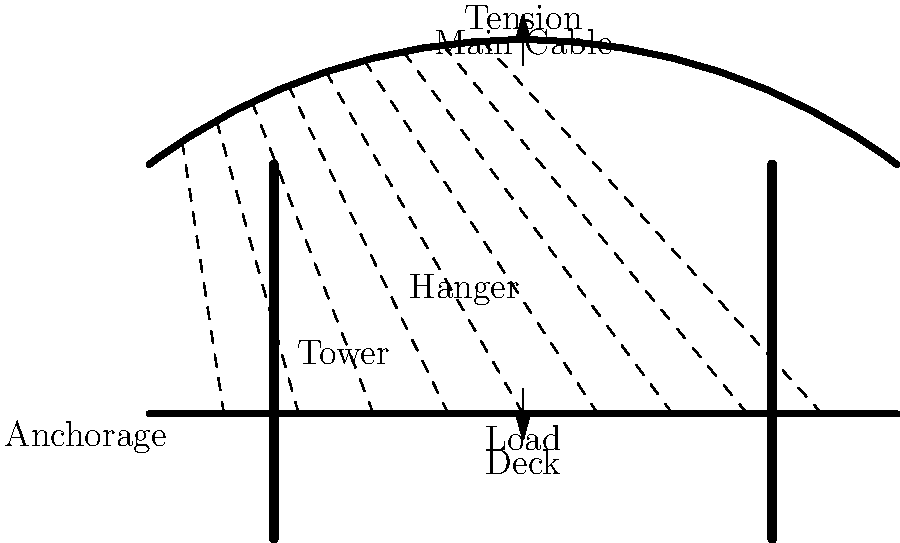In a suspension bridge, how does the main cable transfer the load from the deck to the towers? Explain the role of hangers in this process. To understand the load distribution on a suspension bridge, let's break it down step-by-step:

1. Initial Load: The weight of the deck and any additional loads (like vehicles) create a downward force on the bridge deck.

2. Hangers: The vertical cables called hangers connect the deck to the main cable. They transfer the load from the deck upwards.

3. Main Cable: The main cable, which has a catenary shape, receives the loads from the hangers. This cable is under tension, which can be represented by the equation:

   $$T = \frac{wL^2}{8h}$$

   Where $T$ is the tension, $w$ is the weight per unit length, $L$ is the span length, and $h$ is the sag of the cable.

4. Load Distribution: The tension in the main cable is resolved into vertical and horizontal components at the top of each tower.

5. Towers: The vertical component of the cable tension is transferred to the towers, which are designed to withstand these compressive forces.

6. Anchorages: The horizontal component of the cable tension is resisted by the anchorages at each end of the bridge.

The hangers play a crucial role by:
a) Distributing the deck load evenly along the main cable
b) Allowing the deck to remain relatively horizontal while the main cable takes on a curved shape
c) Transferring both static (permanent) and dynamic (moving) loads to the main cable system

This system allows the bridge to efficiently carry large loads over long spans by primarily using tension in the cables rather than compression or bending in the deck.
Answer: The main cable transfers load through tension, while hangers distribute deck loads to the main cable. 